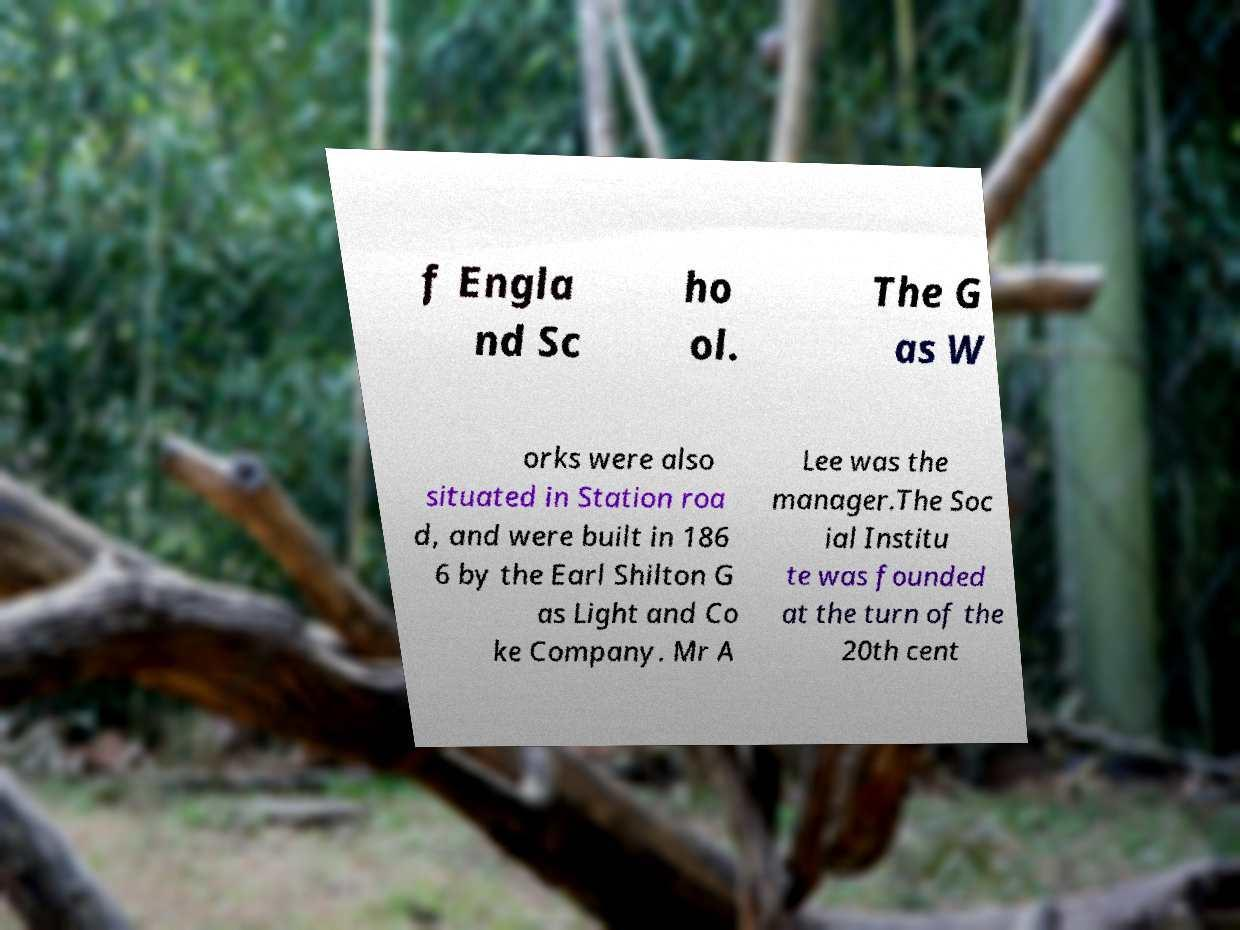Please read and relay the text visible in this image. What does it say? f Engla nd Sc ho ol. The G as W orks were also situated in Station roa d, and were built in 186 6 by the Earl Shilton G as Light and Co ke Company. Mr A Lee was the manager.The Soc ial Institu te was founded at the turn of the 20th cent 